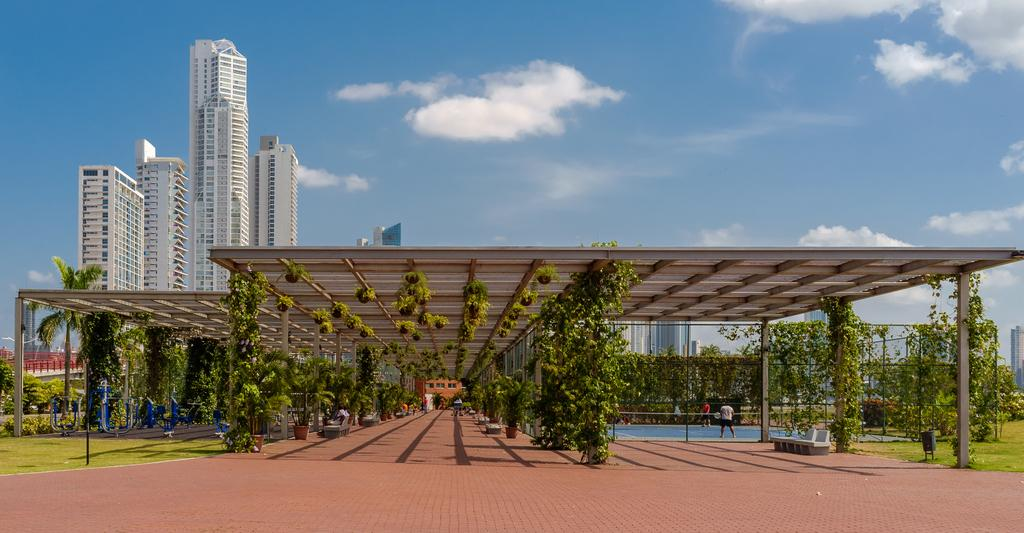What structure is visible in the image? There is a roof in the image. What can be seen below the roof? There are many trees below the roof. What type of recreational area is present on the right side of the image? There is a badminton court on the right side of the image. What is visible behind the roof? There are tall towers behind the roof. What color are the eggs in the image? There are no eggs present in the image. How does the balloon affect the aftermath of the game on the badminton court? There is no balloon or game mentioned in the image, so it's not possible to determine any aftermath or effects. 